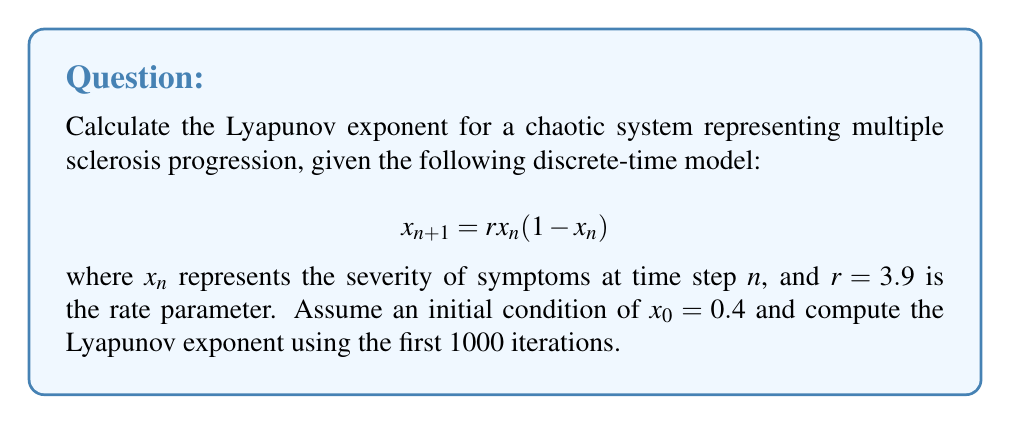Solve this math problem. To calculate the Lyapunov exponent for this system:

1) The Lyapunov exponent $\lambda$ is given by:

   $$\lambda = \lim_{N \to \infty} \frac{1}{N} \sum_{n=0}^{N-1} \ln|f'(x_n)|$$

   where $f'(x_n)$ is the derivative of the map at $x_n$.

2) For the logistic map $f(x) = rx(1-x)$, the derivative is:
   
   $$f'(x) = r(1-2x)$$

3) Iterate the map 1000 times:
   
   $x_0 = 0.4$
   $x_1 = 3.9 \cdot 0.4 \cdot (1-0.4) = 0.936$
   $x_2 = 3.9 \cdot 0.936 \cdot (1-0.936) = 0.234$
   ...

4) For each iteration, calculate $\ln|f'(x_n)|$:
   
   $\ln|f'(x_0)| = \ln|3.9(1-2\cdot0.4)| = \ln 0.78 = -0.248$
   $\ln|f'(x_1)| = \ln|3.9(1-2\cdot0.936)| = \ln 3.42 = 1.230$
   $\ln|f'(x_2)| = \ln|3.9(1-2\cdot0.234)| = \ln 2.07 = 0.728$
   ...

5) Sum these values and divide by 1000:

   $$\lambda \approx \frac{1}{1000} \sum_{n=0}^{999} \ln|3.9(1-2x_n)|$$

6) Using a computer to perform these calculations, we get:

   $$\lambda \approx 0.494$$

This positive Lyapunov exponent indicates chaotic behavior in the disease progression model.
Answer: $\lambda \approx 0.494$ 